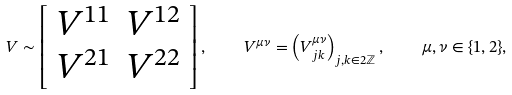Convert formula to latex. <formula><loc_0><loc_0><loc_500><loc_500>V \sim \left [ \begin{array} { c c } V ^ { 1 1 } & V ^ { 1 2 } \\ V ^ { 2 1 } & V ^ { 2 2 } \end{array} \right ] , \quad V ^ { \mu \nu } = \left ( V ^ { \mu \nu } _ { j k } \right ) _ { j , k \in 2 \mathbb { Z } } , \quad \mu , \nu \in \{ 1 , 2 \} ,</formula> 